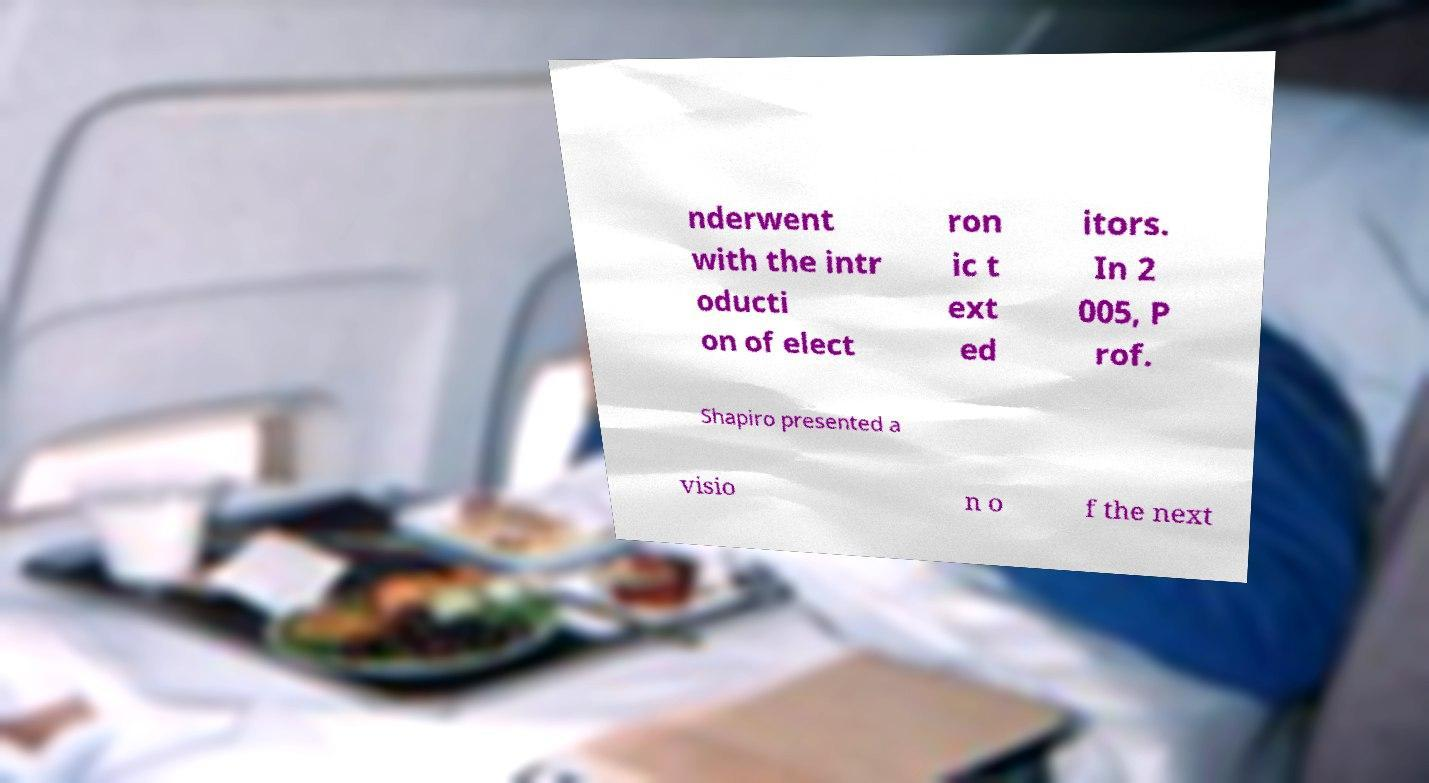What messages or text are displayed in this image? I need them in a readable, typed format. nderwent with the intr oducti on of elect ron ic t ext ed itors. In 2 005, P rof. Shapiro presented a visio n o f the next 